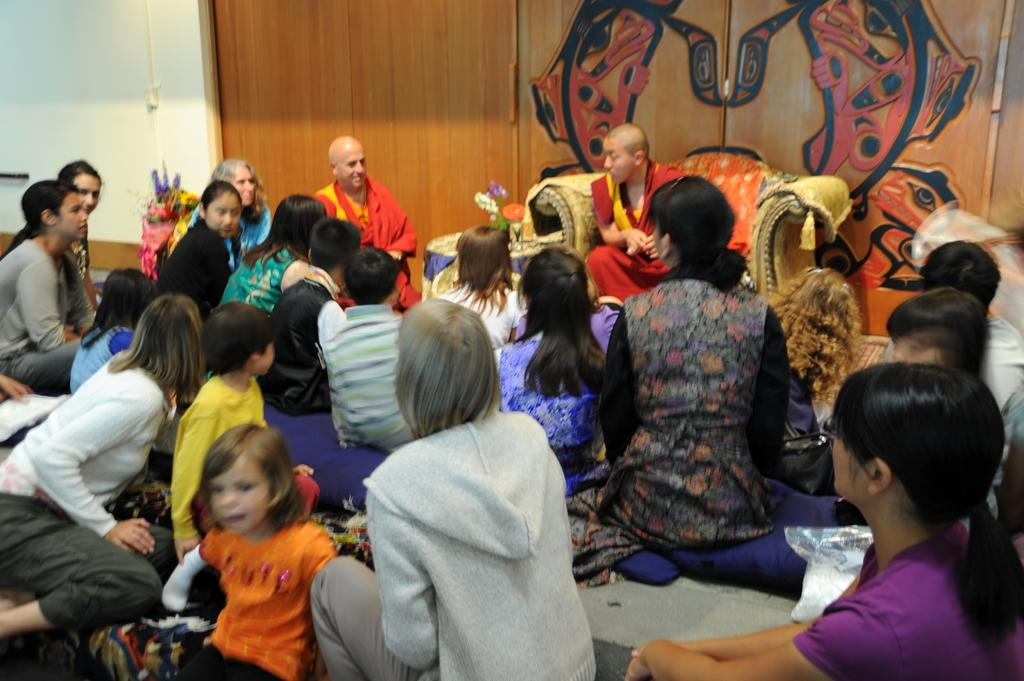What is the general activity of the people in the image? The people in the image are seated. Can you describe the position of the man in the image? There is a man seated on a chair in the image. What architectural features can be seen in the background of the image? Doors are visible in the background of the image. What is the level of pollution in the image? There is no information about pollution in the image, as it focuses on people seated and doors in the background. 